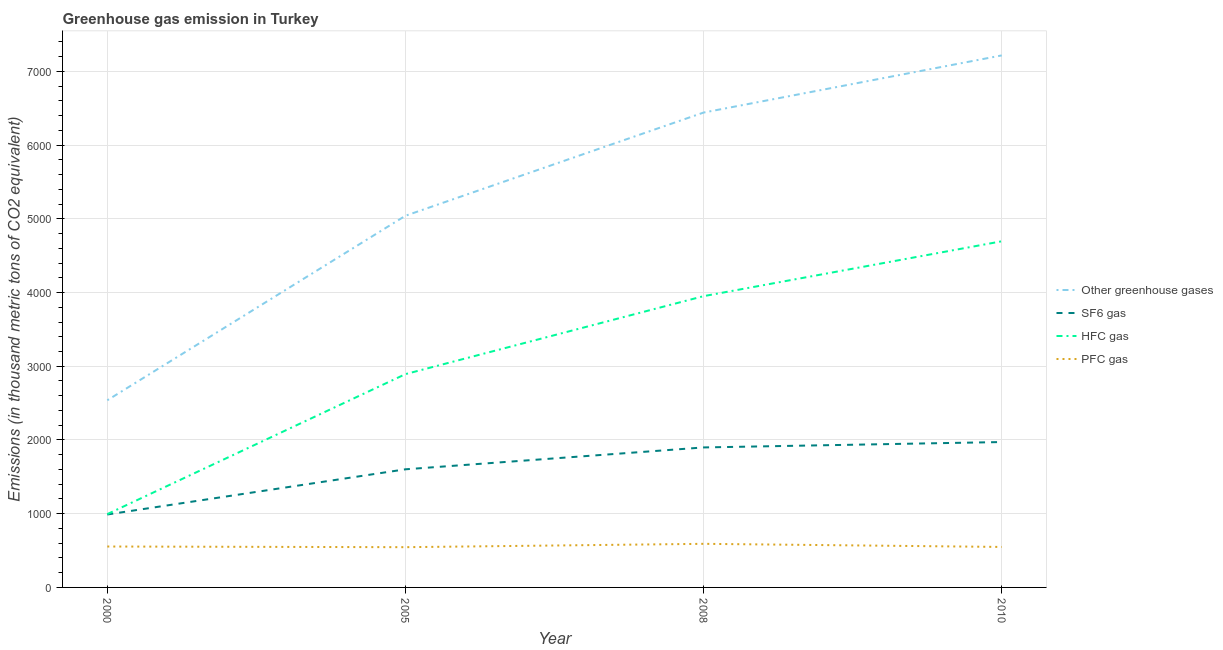Does the line corresponding to emission of hfc gas intersect with the line corresponding to emission of pfc gas?
Your answer should be very brief. No. Is the number of lines equal to the number of legend labels?
Offer a very short reply. Yes. What is the emission of pfc gas in 2010?
Provide a succinct answer. 549. Across all years, what is the maximum emission of pfc gas?
Keep it short and to the point. 591.4. Across all years, what is the minimum emission of sf6 gas?
Your answer should be very brief. 989.2. In which year was the emission of hfc gas minimum?
Make the answer very short. 2000. What is the total emission of sf6 gas in the graph?
Provide a succinct answer. 6462.2. What is the difference between the emission of pfc gas in 2000 and that in 2010?
Offer a terse response. 5.9. What is the difference between the emission of sf6 gas in 2000 and the emission of greenhouse gases in 2008?
Offer a very short reply. -5451.8. What is the average emission of greenhouse gases per year?
Your response must be concise. 5309.2. In the year 2000, what is the difference between the emission of pfc gas and emission of hfc gas?
Your answer should be very brief. -439.5. What is the ratio of the emission of greenhouse gases in 2005 to that in 2008?
Provide a short and direct response. 0.78. Is the emission of hfc gas in 2008 less than that in 2010?
Make the answer very short. Yes. What is the difference between the highest and the second highest emission of hfc gas?
Your answer should be very brief. 744.2. What is the difference between the highest and the lowest emission of sf6 gas?
Your answer should be very brief. 982.8. In how many years, is the emission of sf6 gas greater than the average emission of sf6 gas taken over all years?
Ensure brevity in your answer.  2. Is it the case that in every year, the sum of the emission of hfc gas and emission of pfc gas is greater than the sum of emission of greenhouse gases and emission of sf6 gas?
Your answer should be compact. Yes. Is the emission of sf6 gas strictly greater than the emission of pfc gas over the years?
Make the answer very short. Yes. Is the emission of hfc gas strictly less than the emission of pfc gas over the years?
Your answer should be compact. No. How many lines are there?
Give a very brief answer. 4. How many years are there in the graph?
Ensure brevity in your answer.  4. Are the values on the major ticks of Y-axis written in scientific E-notation?
Provide a short and direct response. No. Does the graph contain grids?
Ensure brevity in your answer.  Yes. How are the legend labels stacked?
Offer a very short reply. Vertical. What is the title of the graph?
Give a very brief answer. Greenhouse gas emission in Turkey. What is the label or title of the Y-axis?
Your response must be concise. Emissions (in thousand metric tons of CO2 equivalent). What is the Emissions (in thousand metric tons of CO2 equivalent) of Other greenhouse gases in 2000?
Make the answer very short. 2538.5. What is the Emissions (in thousand metric tons of CO2 equivalent) of SF6 gas in 2000?
Your answer should be compact. 989.2. What is the Emissions (in thousand metric tons of CO2 equivalent) in HFC gas in 2000?
Provide a succinct answer. 994.4. What is the Emissions (in thousand metric tons of CO2 equivalent) in PFC gas in 2000?
Provide a short and direct response. 554.9. What is the Emissions (in thousand metric tons of CO2 equivalent) in Other greenhouse gases in 2005?
Make the answer very short. 5041.3. What is the Emissions (in thousand metric tons of CO2 equivalent) in SF6 gas in 2005?
Ensure brevity in your answer.  1602.2. What is the Emissions (in thousand metric tons of CO2 equivalent) of HFC gas in 2005?
Offer a terse response. 2893.2. What is the Emissions (in thousand metric tons of CO2 equivalent) of PFC gas in 2005?
Provide a succinct answer. 545.9. What is the Emissions (in thousand metric tons of CO2 equivalent) of Other greenhouse gases in 2008?
Offer a terse response. 6441. What is the Emissions (in thousand metric tons of CO2 equivalent) of SF6 gas in 2008?
Make the answer very short. 1898.8. What is the Emissions (in thousand metric tons of CO2 equivalent) of HFC gas in 2008?
Your response must be concise. 3950.8. What is the Emissions (in thousand metric tons of CO2 equivalent) of PFC gas in 2008?
Make the answer very short. 591.4. What is the Emissions (in thousand metric tons of CO2 equivalent) of Other greenhouse gases in 2010?
Provide a short and direct response. 7216. What is the Emissions (in thousand metric tons of CO2 equivalent) in SF6 gas in 2010?
Give a very brief answer. 1972. What is the Emissions (in thousand metric tons of CO2 equivalent) of HFC gas in 2010?
Offer a terse response. 4695. What is the Emissions (in thousand metric tons of CO2 equivalent) in PFC gas in 2010?
Provide a short and direct response. 549. Across all years, what is the maximum Emissions (in thousand metric tons of CO2 equivalent) in Other greenhouse gases?
Provide a succinct answer. 7216. Across all years, what is the maximum Emissions (in thousand metric tons of CO2 equivalent) of SF6 gas?
Provide a succinct answer. 1972. Across all years, what is the maximum Emissions (in thousand metric tons of CO2 equivalent) in HFC gas?
Your answer should be very brief. 4695. Across all years, what is the maximum Emissions (in thousand metric tons of CO2 equivalent) in PFC gas?
Your response must be concise. 591.4. Across all years, what is the minimum Emissions (in thousand metric tons of CO2 equivalent) in Other greenhouse gases?
Offer a very short reply. 2538.5. Across all years, what is the minimum Emissions (in thousand metric tons of CO2 equivalent) of SF6 gas?
Offer a terse response. 989.2. Across all years, what is the minimum Emissions (in thousand metric tons of CO2 equivalent) in HFC gas?
Keep it short and to the point. 994.4. Across all years, what is the minimum Emissions (in thousand metric tons of CO2 equivalent) of PFC gas?
Your answer should be compact. 545.9. What is the total Emissions (in thousand metric tons of CO2 equivalent) of Other greenhouse gases in the graph?
Offer a terse response. 2.12e+04. What is the total Emissions (in thousand metric tons of CO2 equivalent) in SF6 gas in the graph?
Your answer should be compact. 6462.2. What is the total Emissions (in thousand metric tons of CO2 equivalent) of HFC gas in the graph?
Your answer should be very brief. 1.25e+04. What is the total Emissions (in thousand metric tons of CO2 equivalent) in PFC gas in the graph?
Offer a very short reply. 2241.2. What is the difference between the Emissions (in thousand metric tons of CO2 equivalent) of Other greenhouse gases in 2000 and that in 2005?
Provide a succinct answer. -2502.8. What is the difference between the Emissions (in thousand metric tons of CO2 equivalent) in SF6 gas in 2000 and that in 2005?
Provide a succinct answer. -613. What is the difference between the Emissions (in thousand metric tons of CO2 equivalent) of HFC gas in 2000 and that in 2005?
Your response must be concise. -1898.8. What is the difference between the Emissions (in thousand metric tons of CO2 equivalent) in PFC gas in 2000 and that in 2005?
Offer a terse response. 9. What is the difference between the Emissions (in thousand metric tons of CO2 equivalent) of Other greenhouse gases in 2000 and that in 2008?
Your response must be concise. -3902.5. What is the difference between the Emissions (in thousand metric tons of CO2 equivalent) of SF6 gas in 2000 and that in 2008?
Your answer should be compact. -909.6. What is the difference between the Emissions (in thousand metric tons of CO2 equivalent) of HFC gas in 2000 and that in 2008?
Provide a succinct answer. -2956.4. What is the difference between the Emissions (in thousand metric tons of CO2 equivalent) in PFC gas in 2000 and that in 2008?
Provide a short and direct response. -36.5. What is the difference between the Emissions (in thousand metric tons of CO2 equivalent) of Other greenhouse gases in 2000 and that in 2010?
Make the answer very short. -4677.5. What is the difference between the Emissions (in thousand metric tons of CO2 equivalent) in SF6 gas in 2000 and that in 2010?
Make the answer very short. -982.8. What is the difference between the Emissions (in thousand metric tons of CO2 equivalent) in HFC gas in 2000 and that in 2010?
Make the answer very short. -3700.6. What is the difference between the Emissions (in thousand metric tons of CO2 equivalent) in Other greenhouse gases in 2005 and that in 2008?
Keep it short and to the point. -1399.7. What is the difference between the Emissions (in thousand metric tons of CO2 equivalent) of SF6 gas in 2005 and that in 2008?
Offer a terse response. -296.6. What is the difference between the Emissions (in thousand metric tons of CO2 equivalent) in HFC gas in 2005 and that in 2008?
Provide a short and direct response. -1057.6. What is the difference between the Emissions (in thousand metric tons of CO2 equivalent) in PFC gas in 2005 and that in 2008?
Make the answer very short. -45.5. What is the difference between the Emissions (in thousand metric tons of CO2 equivalent) in Other greenhouse gases in 2005 and that in 2010?
Offer a very short reply. -2174.7. What is the difference between the Emissions (in thousand metric tons of CO2 equivalent) of SF6 gas in 2005 and that in 2010?
Your answer should be very brief. -369.8. What is the difference between the Emissions (in thousand metric tons of CO2 equivalent) in HFC gas in 2005 and that in 2010?
Provide a short and direct response. -1801.8. What is the difference between the Emissions (in thousand metric tons of CO2 equivalent) of Other greenhouse gases in 2008 and that in 2010?
Make the answer very short. -775. What is the difference between the Emissions (in thousand metric tons of CO2 equivalent) of SF6 gas in 2008 and that in 2010?
Keep it short and to the point. -73.2. What is the difference between the Emissions (in thousand metric tons of CO2 equivalent) in HFC gas in 2008 and that in 2010?
Your response must be concise. -744.2. What is the difference between the Emissions (in thousand metric tons of CO2 equivalent) in PFC gas in 2008 and that in 2010?
Offer a very short reply. 42.4. What is the difference between the Emissions (in thousand metric tons of CO2 equivalent) of Other greenhouse gases in 2000 and the Emissions (in thousand metric tons of CO2 equivalent) of SF6 gas in 2005?
Your answer should be compact. 936.3. What is the difference between the Emissions (in thousand metric tons of CO2 equivalent) in Other greenhouse gases in 2000 and the Emissions (in thousand metric tons of CO2 equivalent) in HFC gas in 2005?
Give a very brief answer. -354.7. What is the difference between the Emissions (in thousand metric tons of CO2 equivalent) in Other greenhouse gases in 2000 and the Emissions (in thousand metric tons of CO2 equivalent) in PFC gas in 2005?
Your answer should be compact. 1992.6. What is the difference between the Emissions (in thousand metric tons of CO2 equivalent) of SF6 gas in 2000 and the Emissions (in thousand metric tons of CO2 equivalent) of HFC gas in 2005?
Your answer should be compact. -1904. What is the difference between the Emissions (in thousand metric tons of CO2 equivalent) of SF6 gas in 2000 and the Emissions (in thousand metric tons of CO2 equivalent) of PFC gas in 2005?
Offer a very short reply. 443.3. What is the difference between the Emissions (in thousand metric tons of CO2 equivalent) of HFC gas in 2000 and the Emissions (in thousand metric tons of CO2 equivalent) of PFC gas in 2005?
Keep it short and to the point. 448.5. What is the difference between the Emissions (in thousand metric tons of CO2 equivalent) in Other greenhouse gases in 2000 and the Emissions (in thousand metric tons of CO2 equivalent) in SF6 gas in 2008?
Make the answer very short. 639.7. What is the difference between the Emissions (in thousand metric tons of CO2 equivalent) of Other greenhouse gases in 2000 and the Emissions (in thousand metric tons of CO2 equivalent) of HFC gas in 2008?
Offer a very short reply. -1412.3. What is the difference between the Emissions (in thousand metric tons of CO2 equivalent) in Other greenhouse gases in 2000 and the Emissions (in thousand metric tons of CO2 equivalent) in PFC gas in 2008?
Offer a very short reply. 1947.1. What is the difference between the Emissions (in thousand metric tons of CO2 equivalent) in SF6 gas in 2000 and the Emissions (in thousand metric tons of CO2 equivalent) in HFC gas in 2008?
Ensure brevity in your answer.  -2961.6. What is the difference between the Emissions (in thousand metric tons of CO2 equivalent) in SF6 gas in 2000 and the Emissions (in thousand metric tons of CO2 equivalent) in PFC gas in 2008?
Offer a very short reply. 397.8. What is the difference between the Emissions (in thousand metric tons of CO2 equivalent) of HFC gas in 2000 and the Emissions (in thousand metric tons of CO2 equivalent) of PFC gas in 2008?
Ensure brevity in your answer.  403. What is the difference between the Emissions (in thousand metric tons of CO2 equivalent) of Other greenhouse gases in 2000 and the Emissions (in thousand metric tons of CO2 equivalent) of SF6 gas in 2010?
Ensure brevity in your answer.  566.5. What is the difference between the Emissions (in thousand metric tons of CO2 equivalent) in Other greenhouse gases in 2000 and the Emissions (in thousand metric tons of CO2 equivalent) in HFC gas in 2010?
Your answer should be very brief. -2156.5. What is the difference between the Emissions (in thousand metric tons of CO2 equivalent) in Other greenhouse gases in 2000 and the Emissions (in thousand metric tons of CO2 equivalent) in PFC gas in 2010?
Your answer should be very brief. 1989.5. What is the difference between the Emissions (in thousand metric tons of CO2 equivalent) of SF6 gas in 2000 and the Emissions (in thousand metric tons of CO2 equivalent) of HFC gas in 2010?
Give a very brief answer. -3705.8. What is the difference between the Emissions (in thousand metric tons of CO2 equivalent) in SF6 gas in 2000 and the Emissions (in thousand metric tons of CO2 equivalent) in PFC gas in 2010?
Ensure brevity in your answer.  440.2. What is the difference between the Emissions (in thousand metric tons of CO2 equivalent) of HFC gas in 2000 and the Emissions (in thousand metric tons of CO2 equivalent) of PFC gas in 2010?
Provide a succinct answer. 445.4. What is the difference between the Emissions (in thousand metric tons of CO2 equivalent) of Other greenhouse gases in 2005 and the Emissions (in thousand metric tons of CO2 equivalent) of SF6 gas in 2008?
Your response must be concise. 3142.5. What is the difference between the Emissions (in thousand metric tons of CO2 equivalent) in Other greenhouse gases in 2005 and the Emissions (in thousand metric tons of CO2 equivalent) in HFC gas in 2008?
Provide a short and direct response. 1090.5. What is the difference between the Emissions (in thousand metric tons of CO2 equivalent) of Other greenhouse gases in 2005 and the Emissions (in thousand metric tons of CO2 equivalent) of PFC gas in 2008?
Your response must be concise. 4449.9. What is the difference between the Emissions (in thousand metric tons of CO2 equivalent) in SF6 gas in 2005 and the Emissions (in thousand metric tons of CO2 equivalent) in HFC gas in 2008?
Provide a succinct answer. -2348.6. What is the difference between the Emissions (in thousand metric tons of CO2 equivalent) of SF6 gas in 2005 and the Emissions (in thousand metric tons of CO2 equivalent) of PFC gas in 2008?
Offer a terse response. 1010.8. What is the difference between the Emissions (in thousand metric tons of CO2 equivalent) in HFC gas in 2005 and the Emissions (in thousand metric tons of CO2 equivalent) in PFC gas in 2008?
Offer a terse response. 2301.8. What is the difference between the Emissions (in thousand metric tons of CO2 equivalent) of Other greenhouse gases in 2005 and the Emissions (in thousand metric tons of CO2 equivalent) of SF6 gas in 2010?
Your answer should be compact. 3069.3. What is the difference between the Emissions (in thousand metric tons of CO2 equivalent) of Other greenhouse gases in 2005 and the Emissions (in thousand metric tons of CO2 equivalent) of HFC gas in 2010?
Your answer should be compact. 346.3. What is the difference between the Emissions (in thousand metric tons of CO2 equivalent) of Other greenhouse gases in 2005 and the Emissions (in thousand metric tons of CO2 equivalent) of PFC gas in 2010?
Ensure brevity in your answer.  4492.3. What is the difference between the Emissions (in thousand metric tons of CO2 equivalent) of SF6 gas in 2005 and the Emissions (in thousand metric tons of CO2 equivalent) of HFC gas in 2010?
Keep it short and to the point. -3092.8. What is the difference between the Emissions (in thousand metric tons of CO2 equivalent) of SF6 gas in 2005 and the Emissions (in thousand metric tons of CO2 equivalent) of PFC gas in 2010?
Provide a short and direct response. 1053.2. What is the difference between the Emissions (in thousand metric tons of CO2 equivalent) of HFC gas in 2005 and the Emissions (in thousand metric tons of CO2 equivalent) of PFC gas in 2010?
Ensure brevity in your answer.  2344.2. What is the difference between the Emissions (in thousand metric tons of CO2 equivalent) of Other greenhouse gases in 2008 and the Emissions (in thousand metric tons of CO2 equivalent) of SF6 gas in 2010?
Your answer should be compact. 4469. What is the difference between the Emissions (in thousand metric tons of CO2 equivalent) in Other greenhouse gases in 2008 and the Emissions (in thousand metric tons of CO2 equivalent) in HFC gas in 2010?
Make the answer very short. 1746. What is the difference between the Emissions (in thousand metric tons of CO2 equivalent) in Other greenhouse gases in 2008 and the Emissions (in thousand metric tons of CO2 equivalent) in PFC gas in 2010?
Give a very brief answer. 5892. What is the difference between the Emissions (in thousand metric tons of CO2 equivalent) of SF6 gas in 2008 and the Emissions (in thousand metric tons of CO2 equivalent) of HFC gas in 2010?
Your answer should be compact. -2796.2. What is the difference between the Emissions (in thousand metric tons of CO2 equivalent) in SF6 gas in 2008 and the Emissions (in thousand metric tons of CO2 equivalent) in PFC gas in 2010?
Your answer should be compact. 1349.8. What is the difference between the Emissions (in thousand metric tons of CO2 equivalent) of HFC gas in 2008 and the Emissions (in thousand metric tons of CO2 equivalent) of PFC gas in 2010?
Offer a very short reply. 3401.8. What is the average Emissions (in thousand metric tons of CO2 equivalent) of Other greenhouse gases per year?
Provide a succinct answer. 5309.2. What is the average Emissions (in thousand metric tons of CO2 equivalent) of SF6 gas per year?
Give a very brief answer. 1615.55. What is the average Emissions (in thousand metric tons of CO2 equivalent) of HFC gas per year?
Offer a very short reply. 3133.35. What is the average Emissions (in thousand metric tons of CO2 equivalent) of PFC gas per year?
Your answer should be compact. 560.3. In the year 2000, what is the difference between the Emissions (in thousand metric tons of CO2 equivalent) in Other greenhouse gases and Emissions (in thousand metric tons of CO2 equivalent) in SF6 gas?
Offer a terse response. 1549.3. In the year 2000, what is the difference between the Emissions (in thousand metric tons of CO2 equivalent) in Other greenhouse gases and Emissions (in thousand metric tons of CO2 equivalent) in HFC gas?
Offer a terse response. 1544.1. In the year 2000, what is the difference between the Emissions (in thousand metric tons of CO2 equivalent) in Other greenhouse gases and Emissions (in thousand metric tons of CO2 equivalent) in PFC gas?
Offer a terse response. 1983.6. In the year 2000, what is the difference between the Emissions (in thousand metric tons of CO2 equivalent) in SF6 gas and Emissions (in thousand metric tons of CO2 equivalent) in HFC gas?
Offer a very short reply. -5.2. In the year 2000, what is the difference between the Emissions (in thousand metric tons of CO2 equivalent) of SF6 gas and Emissions (in thousand metric tons of CO2 equivalent) of PFC gas?
Make the answer very short. 434.3. In the year 2000, what is the difference between the Emissions (in thousand metric tons of CO2 equivalent) of HFC gas and Emissions (in thousand metric tons of CO2 equivalent) of PFC gas?
Your response must be concise. 439.5. In the year 2005, what is the difference between the Emissions (in thousand metric tons of CO2 equivalent) of Other greenhouse gases and Emissions (in thousand metric tons of CO2 equivalent) of SF6 gas?
Keep it short and to the point. 3439.1. In the year 2005, what is the difference between the Emissions (in thousand metric tons of CO2 equivalent) in Other greenhouse gases and Emissions (in thousand metric tons of CO2 equivalent) in HFC gas?
Your answer should be compact. 2148.1. In the year 2005, what is the difference between the Emissions (in thousand metric tons of CO2 equivalent) of Other greenhouse gases and Emissions (in thousand metric tons of CO2 equivalent) of PFC gas?
Make the answer very short. 4495.4. In the year 2005, what is the difference between the Emissions (in thousand metric tons of CO2 equivalent) of SF6 gas and Emissions (in thousand metric tons of CO2 equivalent) of HFC gas?
Your response must be concise. -1291. In the year 2005, what is the difference between the Emissions (in thousand metric tons of CO2 equivalent) in SF6 gas and Emissions (in thousand metric tons of CO2 equivalent) in PFC gas?
Keep it short and to the point. 1056.3. In the year 2005, what is the difference between the Emissions (in thousand metric tons of CO2 equivalent) of HFC gas and Emissions (in thousand metric tons of CO2 equivalent) of PFC gas?
Your answer should be very brief. 2347.3. In the year 2008, what is the difference between the Emissions (in thousand metric tons of CO2 equivalent) of Other greenhouse gases and Emissions (in thousand metric tons of CO2 equivalent) of SF6 gas?
Provide a short and direct response. 4542.2. In the year 2008, what is the difference between the Emissions (in thousand metric tons of CO2 equivalent) of Other greenhouse gases and Emissions (in thousand metric tons of CO2 equivalent) of HFC gas?
Offer a very short reply. 2490.2. In the year 2008, what is the difference between the Emissions (in thousand metric tons of CO2 equivalent) of Other greenhouse gases and Emissions (in thousand metric tons of CO2 equivalent) of PFC gas?
Make the answer very short. 5849.6. In the year 2008, what is the difference between the Emissions (in thousand metric tons of CO2 equivalent) of SF6 gas and Emissions (in thousand metric tons of CO2 equivalent) of HFC gas?
Give a very brief answer. -2052. In the year 2008, what is the difference between the Emissions (in thousand metric tons of CO2 equivalent) of SF6 gas and Emissions (in thousand metric tons of CO2 equivalent) of PFC gas?
Offer a very short reply. 1307.4. In the year 2008, what is the difference between the Emissions (in thousand metric tons of CO2 equivalent) of HFC gas and Emissions (in thousand metric tons of CO2 equivalent) of PFC gas?
Give a very brief answer. 3359.4. In the year 2010, what is the difference between the Emissions (in thousand metric tons of CO2 equivalent) of Other greenhouse gases and Emissions (in thousand metric tons of CO2 equivalent) of SF6 gas?
Give a very brief answer. 5244. In the year 2010, what is the difference between the Emissions (in thousand metric tons of CO2 equivalent) in Other greenhouse gases and Emissions (in thousand metric tons of CO2 equivalent) in HFC gas?
Make the answer very short. 2521. In the year 2010, what is the difference between the Emissions (in thousand metric tons of CO2 equivalent) in Other greenhouse gases and Emissions (in thousand metric tons of CO2 equivalent) in PFC gas?
Provide a short and direct response. 6667. In the year 2010, what is the difference between the Emissions (in thousand metric tons of CO2 equivalent) of SF6 gas and Emissions (in thousand metric tons of CO2 equivalent) of HFC gas?
Provide a short and direct response. -2723. In the year 2010, what is the difference between the Emissions (in thousand metric tons of CO2 equivalent) in SF6 gas and Emissions (in thousand metric tons of CO2 equivalent) in PFC gas?
Your response must be concise. 1423. In the year 2010, what is the difference between the Emissions (in thousand metric tons of CO2 equivalent) of HFC gas and Emissions (in thousand metric tons of CO2 equivalent) of PFC gas?
Make the answer very short. 4146. What is the ratio of the Emissions (in thousand metric tons of CO2 equivalent) of Other greenhouse gases in 2000 to that in 2005?
Make the answer very short. 0.5. What is the ratio of the Emissions (in thousand metric tons of CO2 equivalent) of SF6 gas in 2000 to that in 2005?
Your response must be concise. 0.62. What is the ratio of the Emissions (in thousand metric tons of CO2 equivalent) in HFC gas in 2000 to that in 2005?
Give a very brief answer. 0.34. What is the ratio of the Emissions (in thousand metric tons of CO2 equivalent) in PFC gas in 2000 to that in 2005?
Offer a terse response. 1.02. What is the ratio of the Emissions (in thousand metric tons of CO2 equivalent) in Other greenhouse gases in 2000 to that in 2008?
Your response must be concise. 0.39. What is the ratio of the Emissions (in thousand metric tons of CO2 equivalent) in SF6 gas in 2000 to that in 2008?
Ensure brevity in your answer.  0.52. What is the ratio of the Emissions (in thousand metric tons of CO2 equivalent) in HFC gas in 2000 to that in 2008?
Your response must be concise. 0.25. What is the ratio of the Emissions (in thousand metric tons of CO2 equivalent) in PFC gas in 2000 to that in 2008?
Ensure brevity in your answer.  0.94. What is the ratio of the Emissions (in thousand metric tons of CO2 equivalent) in Other greenhouse gases in 2000 to that in 2010?
Your answer should be compact. 0.35. What is the ratio of the Emissions (in thousand metric tons of CO2 equivalent) of SF6 gas in 2000 to that in 2010?
Offer a terse response. 0.5. What is the ratio of the Emissions (in thousand metric tons of CO2 equivalent) of HFC gas in 2000 to that in 2010?
Your answer should be very brief. 0.21. What is the ratio of the Emissions (in thousand metric tons of CO2 equivalent) of PFC gas in 2000 to that in 2010?
Make the answer very short. 1.01. What is the ratio of the Emissions (in thousand metric tons of CO2 equivalent) of Other greenhouse gases in 2005 to that in 2008?
Your answer should be compact. 0.78. What is the ratio of the Emissions (in thousand metric tons of CO2 equivalent) of SF6 gas in 2005 to that in 2008?
Your response must be concise. 0.84. What is the ratio of the Emissions (in thousand metric tons of CO2 equivalent) in HFC gas in 2005 to that in 2008?
Make the answer very short. 0.73. What is the ratio of the Emissions (in thousand metric tons of CO2 equivalent) in Other greenhouse gases in 2005 to that in 2010?
Make the answer very short. 0.7. What is the ratio of the Emissions (in thousand metric tons of CO2 equivalent) of SF6 gas in 2005 to that in 2010?
Give a very brief answer. 0.81. What is the ratio of the Emissions (in thousand metric tons of CO2 equivalent) in HFC gas in 2005 to that in 2010?
Make the answer very short. 0.62. What is the ratio of the Emissions (in thousand metric tons of CO2 equivalent) in PFC gas in 2005 to that in 2010?
Provide a short and direct response. 0.99. What is the ratio of the Emissions (in thousand metric tons of CO2 equivalent) of Other greenhouse gases in 2008 to that in 2010?
Provide a succinct answer. 0.89. What is the ratio of the Emissions (in thousand metric tons of CO2 equivalent) in SF6 gas in 2008 to that in 2010?
Keep it short and to the point. 0.96. What is the ratio of the Emissions (in thousand metric tons of CO2 equivalent) in HFC gas in 2008 to that in 2010?
Offer a terse response. 0.84. What is the ratio of the Emissions (in thousand metric tons of CO2 equivalent) in PFC gas in 2008 to that in 2010?
Offer a very short reply. 1.08. What is the difference between the highest and the second highest Emissions (in thousand metric tons of CO2 equivalent) in Other greenhouse gases?
Offer a very short reply. 775. What is the difference between the highest and the second highest Emissions (in thousand metric tons of CO2 equivalent) in SF6 gas?
Give a very brief answer. 73.2. What is the difference between the highest and the second highest Emissions (in thousand metric tons of CO2 equivalent) of HFC gas?
Your answer should be very brief. 744.2. What is the difference between the highest and the second highest Emissions (in thousand metric tons of CO2 equivalent) in PFC gas?
Your answer should be very brief. 36.5. What is the difference between the highest and the lowest Emissions (in thousand metric tons of CO2 equivalent) of Other greenhouse gases?
Your answer should be very brief. 4677.5. What is the difference between the highest and the lowest Emissions (in thousand metric tons of CO2 equivalent) of SF6 gas?
Provide a short and direct response. 982.8. What is the difference between the highest and the lowest Emissions (in thousand metric tons of CO2 equivalent) in HFC gas?
Offer a terse response. 3700.6. What is the difference between the highest and the lowest Emissions (in thousand metric tons of CO2 equivalent) in PFC gas?
Give a very brief answer. 45.5. 